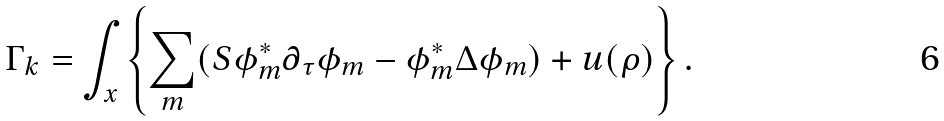<formula> <loc_0><loc_0><loc_500><loc_500>\Gamma _ { k } = \int _ { x } \left \{ \sum _ { m } ( S \phi ^ { * } _ { m } \partial _ { \tau } \phi _ { m } - \phi ^ { * } _ { m } \Delta \phi _ { m } ) + u ( \rho ) \right \} .</formula> 